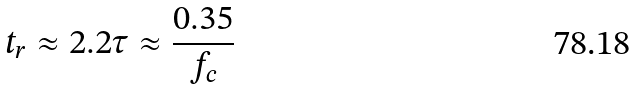<formula> <loc_0><loc_0><loc_500><loc_500>t _ { r } \approx 2 . 2 \tau \approx \frac { 0 . 3 5 } { f _ { c } }</formula> 